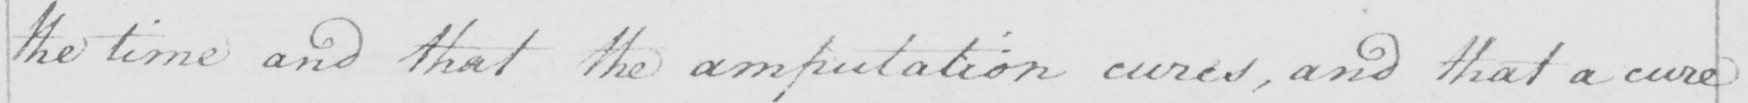Please provide the text content of this handwritten line. the time and that the amputation cured , and that a cure 